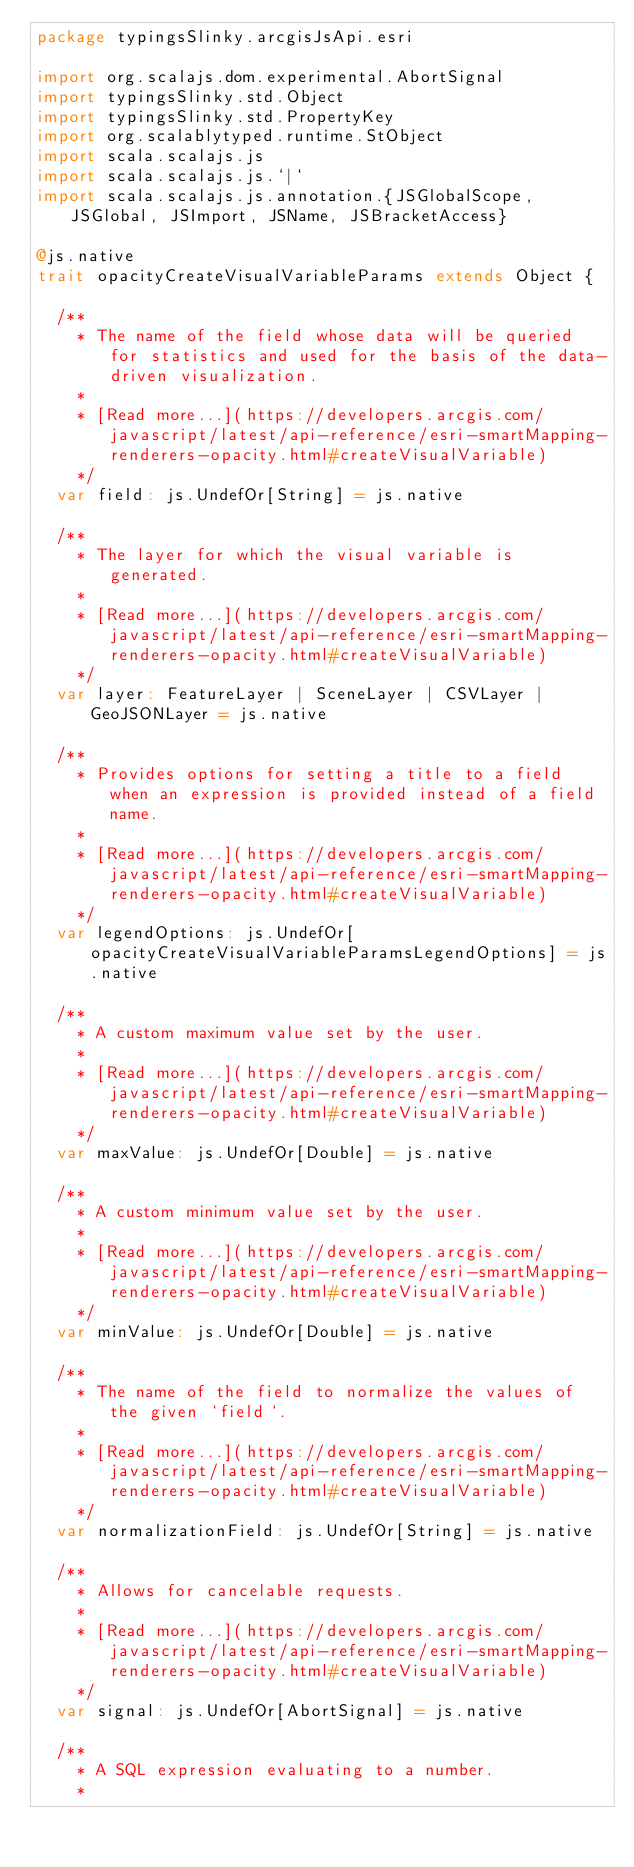Convert code to text. <code><loc_0><loc_0><loc_500><loc_500><_Scala_>package typingsSlinky.arcgisJsApi.esri

import org.scalajs.dom.experimental.AbortSignal
import typingsSlinky.std.Object
import typingsSlinky.std.PropertyKey
import org.scalablytyped.runtime.StObject
import scala.scalajs.js
import scala.scalajs.js.`|`
import scala.scalajs.js.annotation.{JSGlobalScope, JSGlobal, JSImport, JSName, JSBracketAccess}

@js.native
trait opacityCreateVisualVariableParams extends Object {
  
  /**
    * The name of the field whose data will be queried for statistics and used for the basis of the data-driven visualization.
    *
    * [Read more...](https://developers.arcgis.com/javascript/latest/api-reference/esri-smartMapping-renderers-opacity.html#createVisualVariable)
    */
  var field: js.UndefOr[String] = js.native
  
  /**
    * The layer for which the visual variable is generated.
    *
    * [Read more...](https://developers.arcgis.com/javascript/latest/api-reference/esri-smartMapping-renderers-opacity.html#createVisualVariable)
    */
  var layer: FeatureLayer | SceneLayer | CSVLayer | GeoJSONLayer = js.native
  
  /**
    * Provides options for setting a title to a field when an expression is provided instead of a field name.
    *
    * [Read more...](https://developers.arcgis.com/javascript/latest/api-reference/esri-smartMapping-renderers-opacity.html#createVisualVariable)
    */
  var legendOptions: js.UndefOr[opacityCreateVisualVariableParamsLegendOptions] = js.native
  
  /**
    * A custom maximum value set by the user.
    *
    * [Read more...](https://developers.arcgis.com/javascript/latest/api-reference/esri-smartMapping-renderers-opacity.html#createVisualVariable)
    */
  var maxValue: js.UndefOr[Double] = js.native
  
  /**
    * A custom minimum value set by the user.
    *
    * [Read more...](https://developers.arcgis.com/javascript/latest/api-reference/esri-smartMapping-renderers-opacity.html#createVisualVariable)
    */
  var minValue: js.UndefOr[Double] = js.native
  
  /**
    * The name of the field to normalize the values of the given `field`.
    *
    * [Read more...](https://developers.arcgis.com/javascript/latest/api-reference/esri-smartMapping-renderers-opacity.html#createVisualVariable)
    */
  var normalizationField: js.UndefOr[String] = js.native
  
  /**
    * Allows for cancelable requests.
    *
    * [Read more...](https://developers.arcgis.com/javascript/latest/api-reference/esri-smartMapping-renderers-opacity.html#createVisualVariable)
    */
  var signal: js.UndefOr[AbortSignal] = js.native
  
  /**
    * A SQL expression evaluating to a number.
    *</code> 